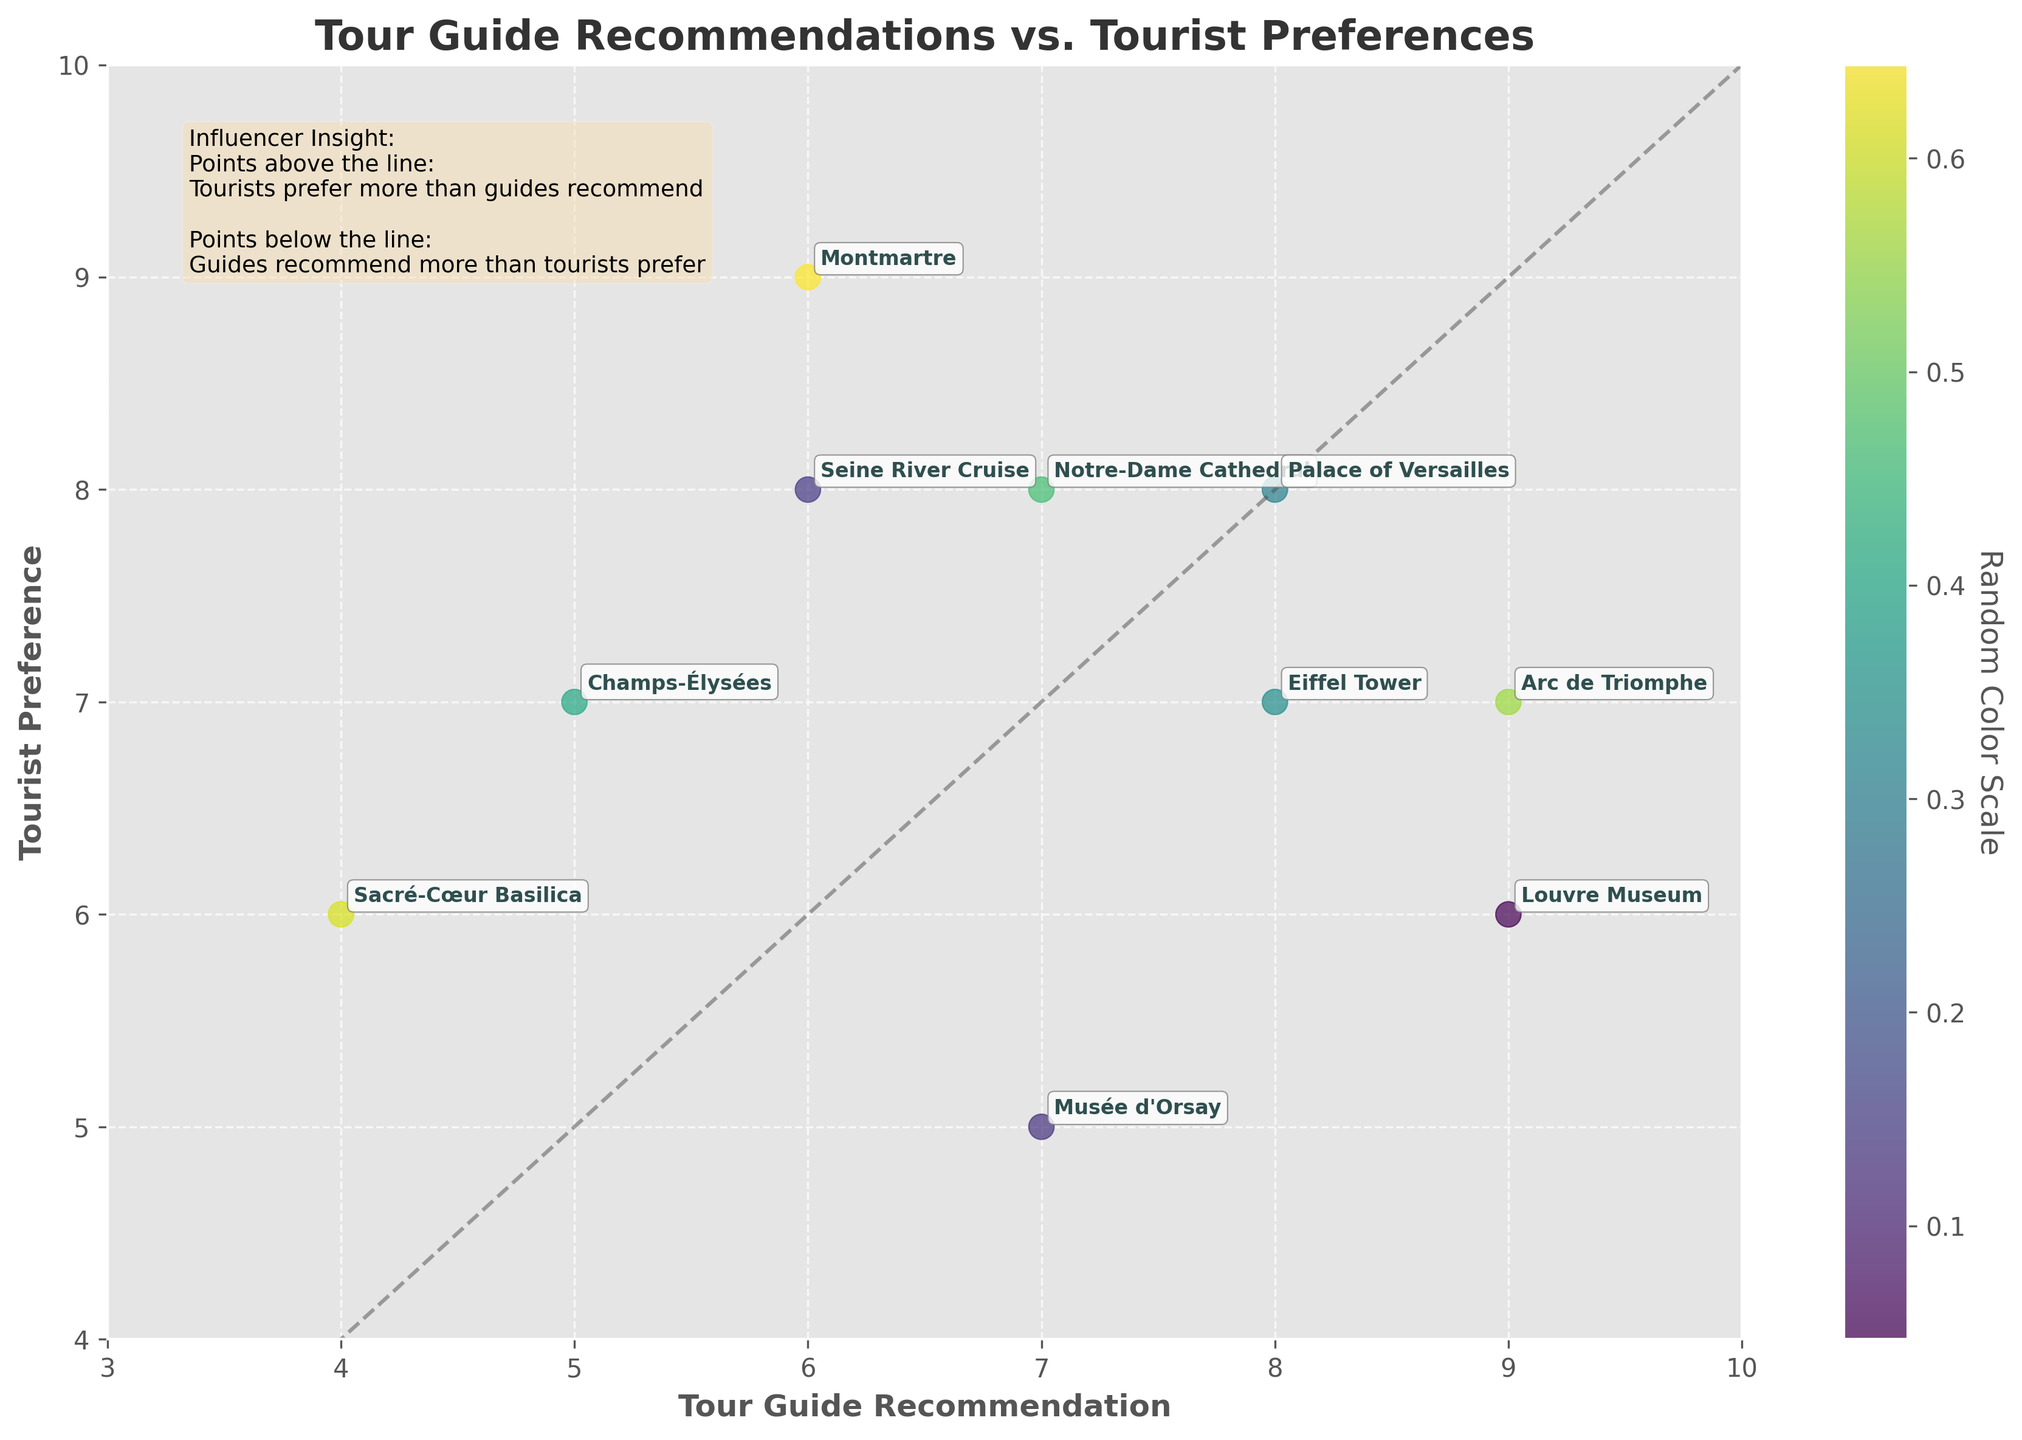What's the title of the figure? The title is displayed prominently at the top of the figure. It usually provides a concise description of what the figure represents.
Answer: Tour Guide Recommendations vs. Tourist Preferences How many data points are in the figure? Each data point represents an attraction and is marked by a scatter point. By visually counting these points, we determine the total number.
Answer: 10 Which attraction has the highest tour guide recommendation? To determine this, we look at the x-axis values and find the highest point, then check the corresponding label.
Answer: Louvre Museum Which attraction does the plot suggest tourists prefer more than guides recommend? To find this, we look for points above the diagonal line, as these represent tourist preferences being higher than guide recommendations.
Answer: Montmartre How many attractions have a tourist preference higher than 7? By examining the y-axis values and counting the points that fall above the value of 7, we determine the attractions in this category.
Answer: 6 What’s the tourist preference for the Eiffel Tower? Locate the data point labeled "Eiffel Tower" and find its position on the y-axis.
Answer: 7 Which attraction shows the largest disagreement between tour guide recommendation and tourist preference? Calculate the absolute difference between tour guide recommendations and tourist preferences for each attraction, and identify the one with the largest difference.
Answer: Louvre Museum What's the trend suggested by the diagonal line in the plot? The diagonal line helps compare the tour guide recommendations and tourist preferences. Points above indicate higher tourist preference, points below indicate higher tour guide recommendation, and points on the line suggest equal recommendation and preference.
Answer: Points above the line indicate tourist preference more than guide recommendation; points below indicate the reverse Which attractions have both tour guide recommendation and tourist preference equal to 8? Locate the intersection of x=8 and y=8, and identify the point(s) found at that location.
Answer: Palace of Versailles What's the general relationship between tour guide recommendations and tourist preferences in the plot? Analyze the distribution of points relative to the diagonal line to understand the overall pattern.
Answer: Generally close, with some discrepancies 